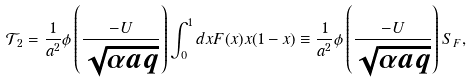Convert formula to latex. <formula><loc_0><loc_0><loc_500><loc_500>\mathcal { T } _ { 2 } = \frac { 1 } { a ^ { 2 } } \phi \left ( \frac { - U } { \sqrt { \alpha a q } } \right ) \int _ { 0 } ^ { 1 } d x F ( x ) x ( 1 - x ) \equiv \frac { 1 } { a ^ { 2 } } \phi \left ( \frac { - U } { \sqrt { \alpha a q } } \right ) S _ { F } ,</formula> 